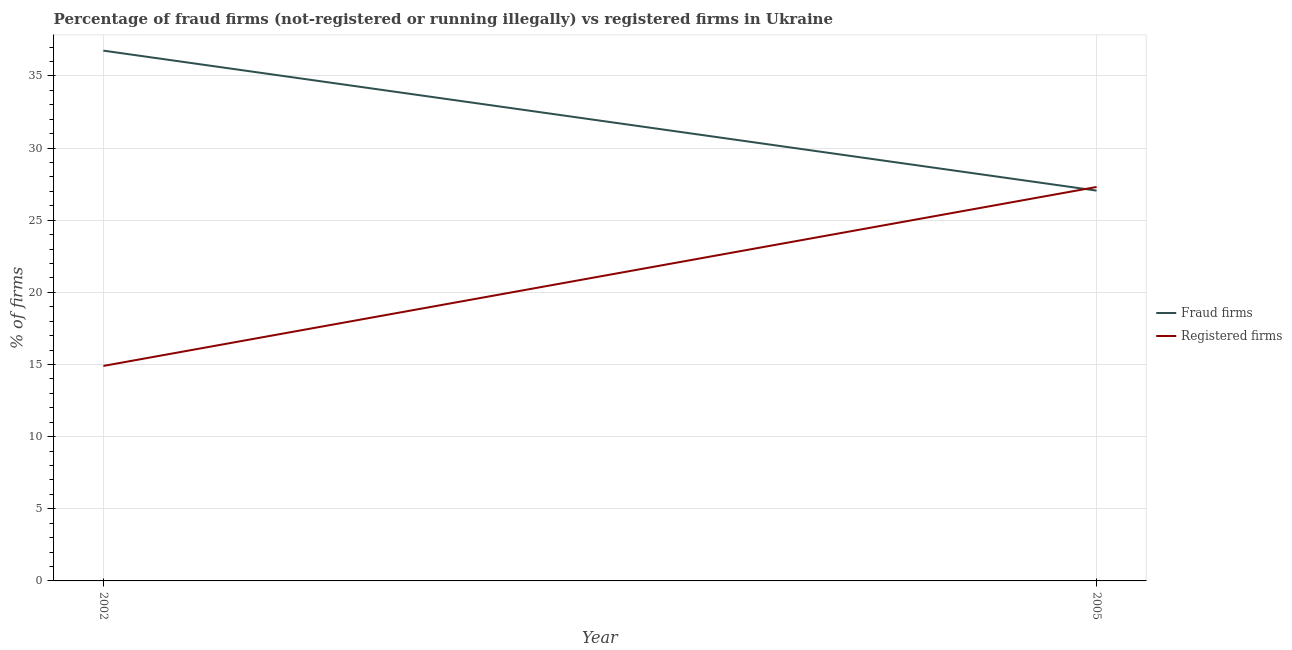How many different coloured lines are there?
Your answer should be compact. 2. What is the percentage of fraud firms in 2002?
Make the answer very short. 36.75. Across all years, what is the maximum percentage of fraud firms?
Provide a succinct answer. 36.75. Across all years, what is the minimum percentage of registered firms?
Keep it short and to the point. 14.9. In which year was the percentage of fraud firms maximum?
Offer a very short reply. 2002. What is the total percentage of fraud firms in the graph?
Provide a succinct answer. 63.8. What is the difference between the percentage of registered firms in 2005 and the percentage of fraud firms in 2002?
Offer a very short reply. -9.45. What is the average percentage of fraud firms per year?
Offer a very short reply. 31.9. In how many years, is the percentage of registered firms greater than 7 %?
Offer a terse response. 2. What is the ratio of the percentage of fraud firms in 2002 to that in 2005?
Ensure brevity in your answer.  1.36. In how many years, is the percentage of fraud firms greater than the average percentage of fraud firms taken over all years?
Offer a very short reply. 1. Is the percentage of fraud firms strictly greater than the percentage of registered firms over the years?
Ensure brevity in your answer.  No. Is the percentage of registered firms strictly less than the percentage of fraud firms over the years?
Ensure brevity in your answer.  No. How many lines are there?
Give a very brief answer. 2. How many years are there in the graph?
Keep it short and to the point. 2. Does the graph contain grids?
Provide a short and direct response. Yes. What is the title of the graph?
Give a very brief answer. Percentage of fraud firms (not-registered or running illegally) vs registered firms in Ukraine. Does "External balance on goods" appear as one of the legend labels in the graph?
Provide a short and direct response. No. What is the label or title of the Y-axis?
Offer a terse response. % of firms. What is the % of firms of Fraud firms in 2002?
Keep it short and to the point. 36.75. What is the % of firms of Fraud firms in 2005?
Offer a very short reply. 27.05. What is the % of firms of Registered firms in 2005?
Ensure brevity in your answer.  27.3. Across all years, what is the maximum % of firms in Fraud firms?
Provide a succinct answer. 36.75. Across all years, what is the maximum % of firms of Registered firms?
Offer a very short reply. 27.3. Across all years, what is the minimum % of firms of Fraud firms?
Provide a short and direct response. 27.05. Across all years, what is the minimum % of firms of Registered firms?
Provide a succinct answer. 14.9. What is the total % of firms of Fraud firms in the graph?
Ensure brevity in your answer.  63.8. What is the total % of firms in Registered firms in the graph?
Ensure brevity in your answer.  42.2. What is the difference between the % of firms of Fraud firms in 2002 and the % of firms of Registered firms in 2005?
Provide a short and direct response. 9.45. What is the average % of firms in Fraud firms per year?
Make the answer very short. 31.9. What is the average % of firms in Registered firms per year?
Keep it short and to the point. 21.1. In the year 2002, what is the difference between the % of firms of Fraud firms and % of firms of Registered firms?
Offer a terse response. 21.85. In the year 2005, what is the difference between the % of firms in Fraud firms and % of firms in Registered firms?
Provide a short and direct response. -0.25. What is the ratio of the % of firms in Fraud firms in 2002 to that in 2005?
Make the answer very short. 1.36. What is the ratio of the % of firms in Registered firms in 2002 to that in 2005?
Give a very brief answer. 0.55. What is the difference between the highest and the lowest % of firms in Registered firms?
Provide a succinct answer. 12.4. 